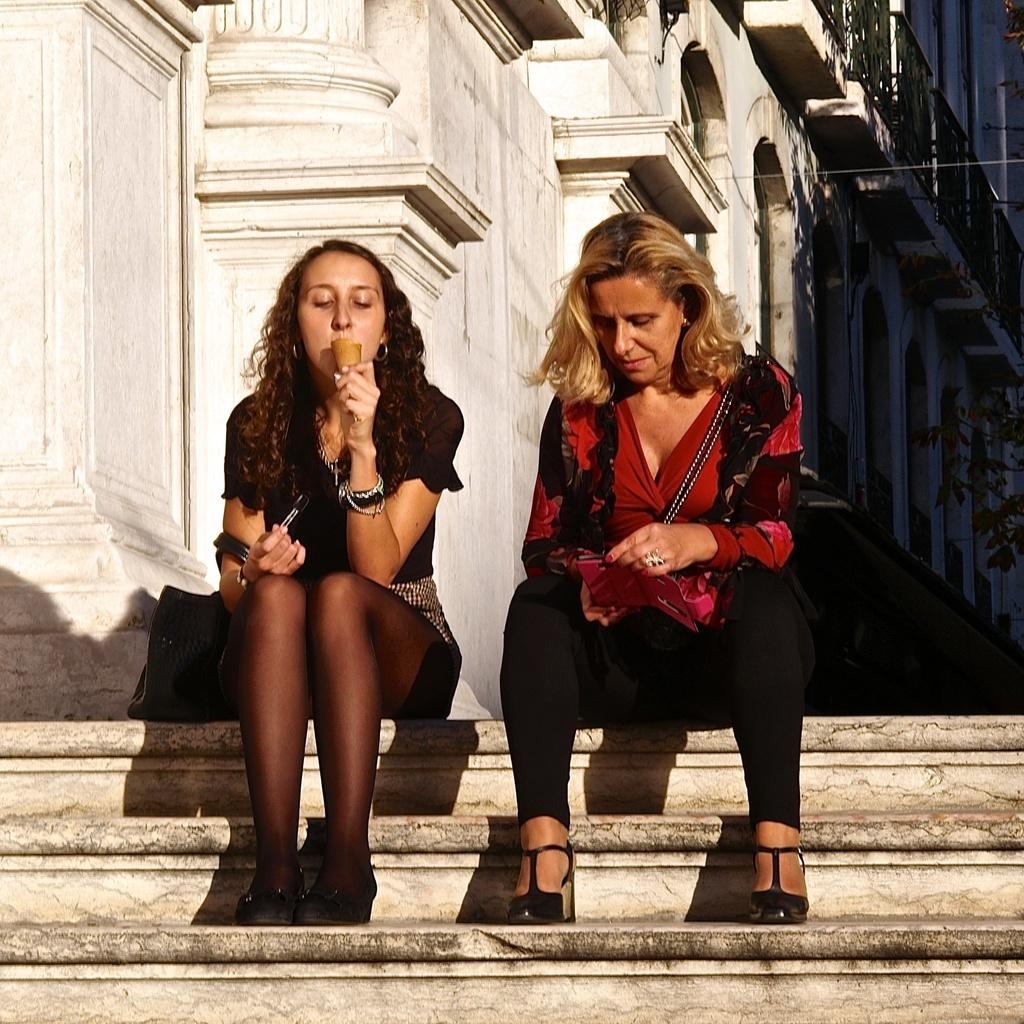How many people are in the image? There are 2 women in the image. What are the women doing in the image? The women are sitting on the stairs. Where are the stairs located in relation to the building? The stairs are in front of a building. What type of joke is the kettle telling the women in the image? There is no kettle present in the image, and therefore no such interaction can be observed. 